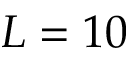<formula> <loc_0><loc_0><loc_500><loc_500>L = 1 0</formula> 